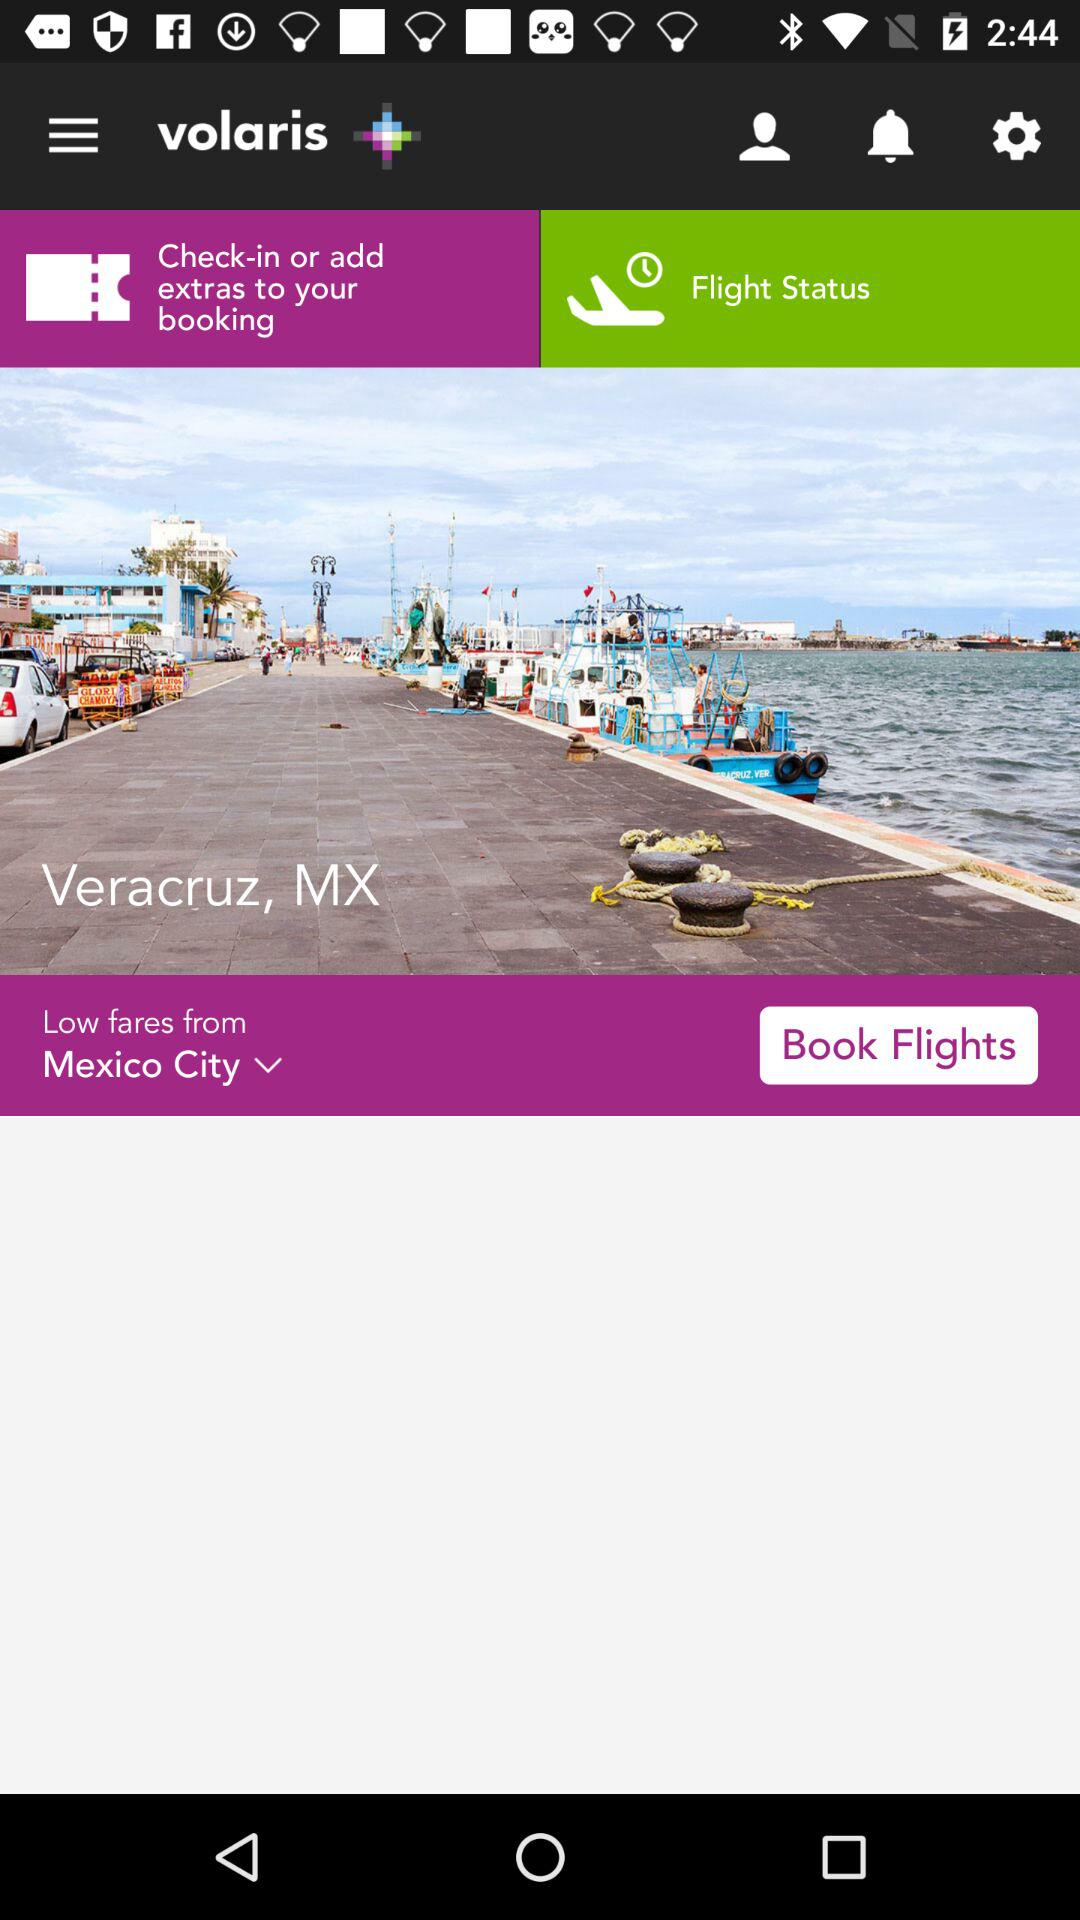Which city has been selected for low fares? The selected city is Mexico City. 